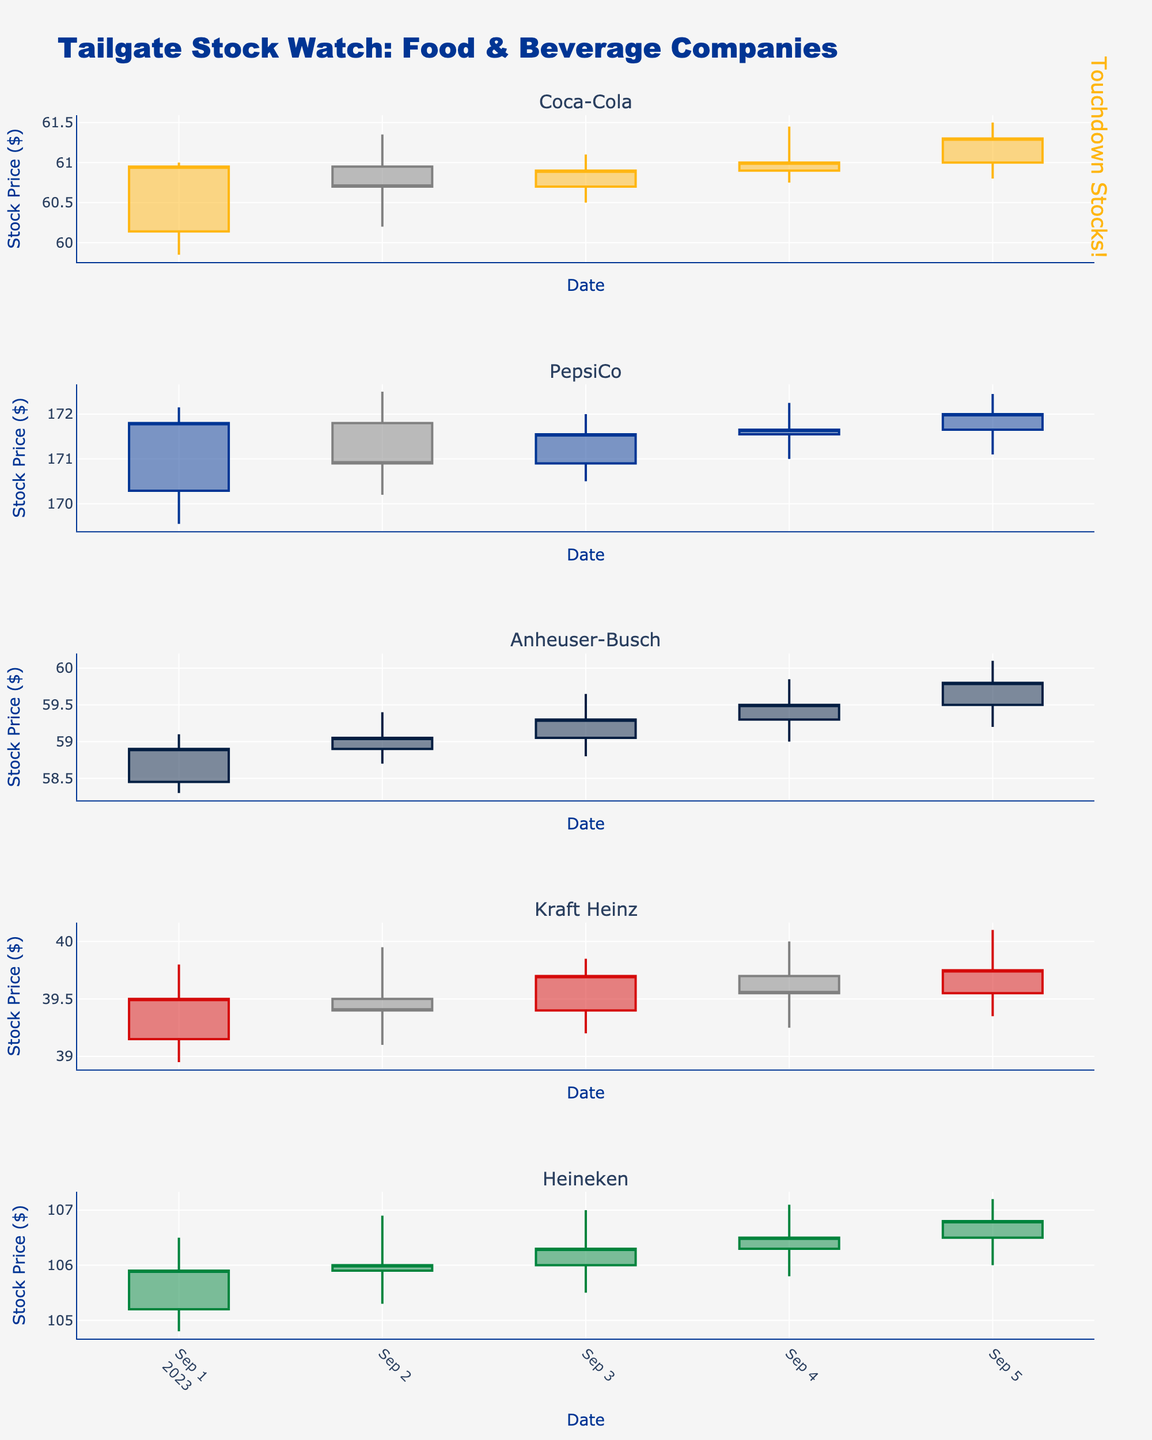How many companies are represented in the candlestick plots? The figure contains several rows, each representing a different company. By counting the number of subplot titles, we can determine the number of companies in the figure.
Answer: 5 What is the highest stock price reached by PepsiCo during the given dates? By examining the highest point on PepsiCo's candlestick plot, we see the peak value in the "High" data, which is 172.50 on September 2nd.
Answer: 172.50 Which company had the greatest increase in closing stock price from September 1st to September 5th? By comparing the closing prices on September 1st and 5th for each company:
- Coca-Cola: 60.95 to 61.30 (+0.35)
- PepsiCo: 171.80 to 172.00 (+0.20)
- Anheuser-Busch: 58.90 to 59.80 (+0.90)
- Kraft Heinz: 39.50 to 39.75 (+0.25)
- Heineken: 105.90 to 106.80 (+0.90)
Anheuser-Busch and Heineken both increased by 0.90.
Answer: Anheuser-Busch, Heineken What is the average closing stock price for Kraft Heinz over the given dates? Sum of closing prices for Kraft Heinz over the 5 days: 39.50 + 39.40 + 39.70 + 39.55 + 39.75 = 197.90. Divide by the number of days (5) to find the average.
Answer: 39.58 Which company had the highest trading volume on September 5th? By examining the trading volume data for each company on September 5th:
- Coca-Cola: 12300000
- PepsiCo: 9400000
- Anheuser-Busch: 8300000
- Kraft Heinz: 13300000
- Heineken: 7050000
Kraft Heinz has the highest trading volume.
Answer: Kraft Heinz How did Coca-Cola's stock price trend over the given dates? By looking at the opening and closing prices over the 5 days:
- September 1st: 60.14 to 60.95 (increase)
- September 2nd: 60.95 to 60.70 (decrease)
- September 3rd: 60.70 to 60.90 (increase)
- September 4th: 60.90 to 61.00 (increase)
- September 5th: 61.00 to 61.30 (increase)
Coca-Cola's stock price mostly increased, with a slight dip on September 2nd.
Answer: Mostly increasing with a small dip on September 2nd 